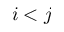Convert formula to latex. <formula><loc_0><loc_0><loc_500><loc_500>i < j</formula> 